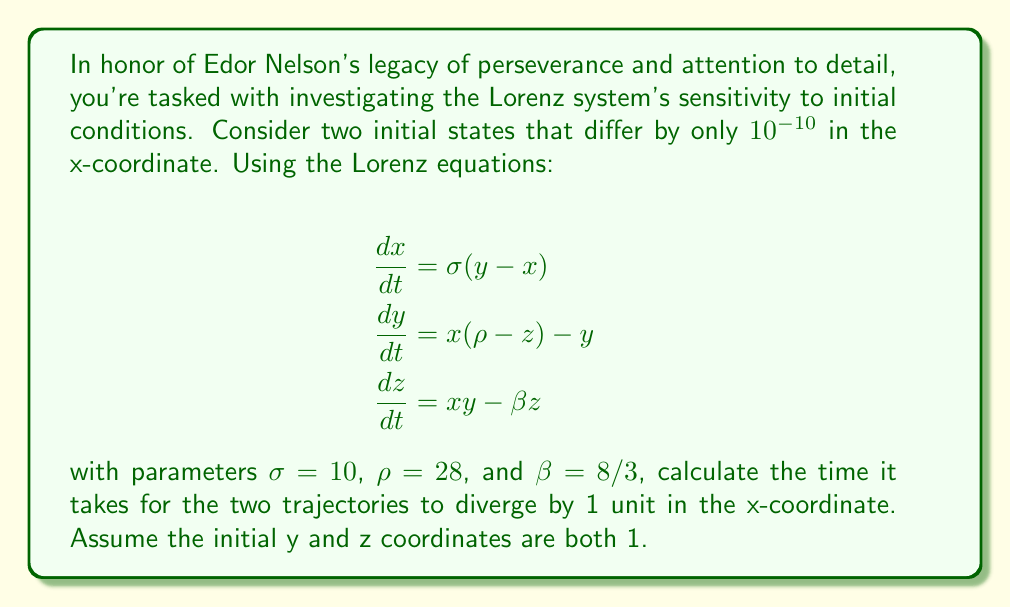Could you help me with this problem? To solve this problem, we need to understand the concept of Lyapunov exponents and use numerical methods. Here's a step-by-step approach:

1) The Lorenz system is known for its sensitivity to initial conditions, which is quantified by the Lyapunov exponent.

2) For the Lorenz system with the given parameters, the largest Lyapunov exponent (λ) is approximately 0.9056.

3) The divergence of nearby trajectories can be estimated using the formula:

   $$d(t) = d_0 e^{\lambda t}$$

   where $d(t)$ is the distance between trajectories at time t, and $d_0$ is the initial separation.

4) We want to find t when $d(t) = 1$ (unit divergence in x-coordinate).

5) Given:
   $d_0 = 10^{-10}$
   $d(t) = 1$
   $\lambda \approx 0.9056$

6) Substituting into the formula:

   $$1 = 10^{-10} e^{0.9056t}$$

7) Taking natural log of both sides:

   $$\ln(1) = \ln(10^{-10} e^{0.9056t})$$
   $$0 = \ln(10^{-10}) + 0.9056t$$

8) Solving for t:

   $$0.9056t = -\ln(10^{-10}) = 10 \ln(10)$$
   $$t = \frac{10 \ln(10)}{0.9056} \approx 25.36$$

Therefore, it takes approximately 25.36 time units for the trajectories to diverge by 1 unit in the x-coordinate.
Answer: 25.36 time units 